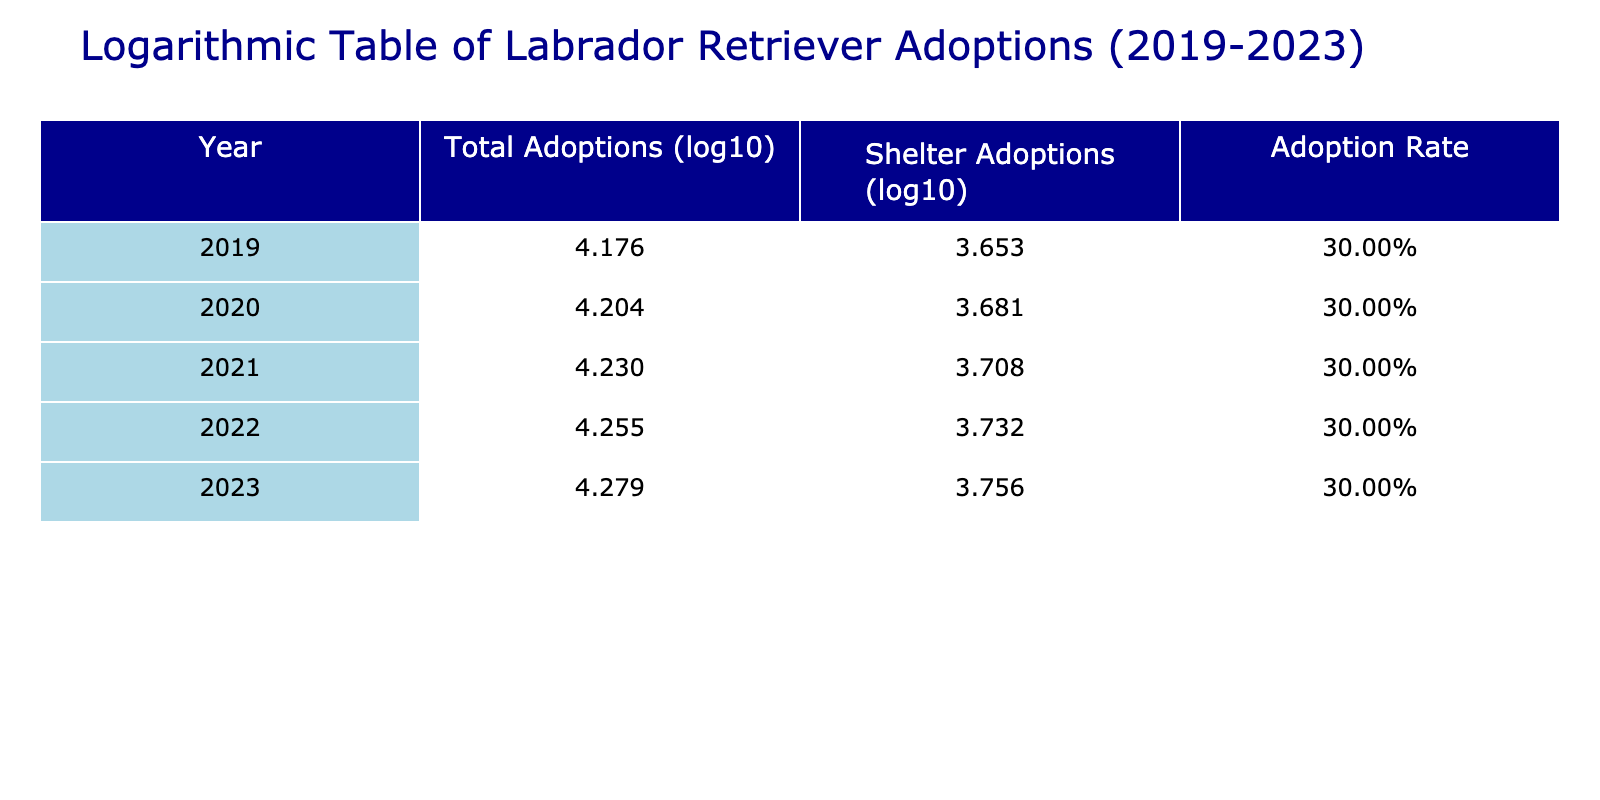What was the total number of Labrador adoptions in 2021? The table lists the total adoptions for each year, and in 2021, the value for Total Labrador Adoptions is 17000.
Answer: 17000 What is the logarithm (base 10) of shelter adoptions in 2020? In the table, the Log Shelter Adoptions for the year 2020 is provided directly as approximately 3.681.
Answer: 3.681 How many more shelter adoptions were there in 2023 compared to 2019? From the table, the number of shelter adoptions in 2023 is 5700 and in 2019 is 4500. The difference is 5700 - 4500 = 1200.
Answer: 1200 What is the adoption rate from shelters for the year 2022? According to the table, the Adoption Rate for shelters in 2022 is given as 0.30, or 30%.
Answer: 30% Is the adoption rate from shelters the same for all five years? By looking at the Adoption Rate column for each year, we can see it has been consistently 0.30 for all five years, indicating that the rate has not changed.
Answer: Yes What is the average number of total adoptions from 2019 to 2023? The total adoptions across the five years are 15000 + 16000 + 17000 + 18000 + 19000 = 85000. To find the average, we divide by the number of years: 85000 / 5 = 17000.
Answer: 17000 In which year was the highest number of shelter adoptions recorded? Looking at the Adoptions From Shelters column, the values are 4500, 4800, 5100, 5400, and 5700 for the respective years. The highest value is 5700 in 2023.
Answer: 2023 What was the logarithmic value of total adoptions in 2019? The Log Total Adoptions for the year 2019 can be identified directly in the table and is approximately 4.176.
Answer: 4.176 Did the total number of Labrador adoptions increase every year from 2019 to 2023? Observing the Total Labrador Adoptions for each year, they have increased from 15000 to 19000, confirming a consistent increase yearly.
Answer: Yes 